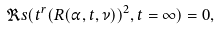Convert formula to latex. <formula><loc_0><loc_0><loc_500><loc_500>\Re s ( t ^ { r } ( R ( \alpha , t , \nu ) ) ^ { 2 } , t = \infty ) = 0 , \,</formula> 